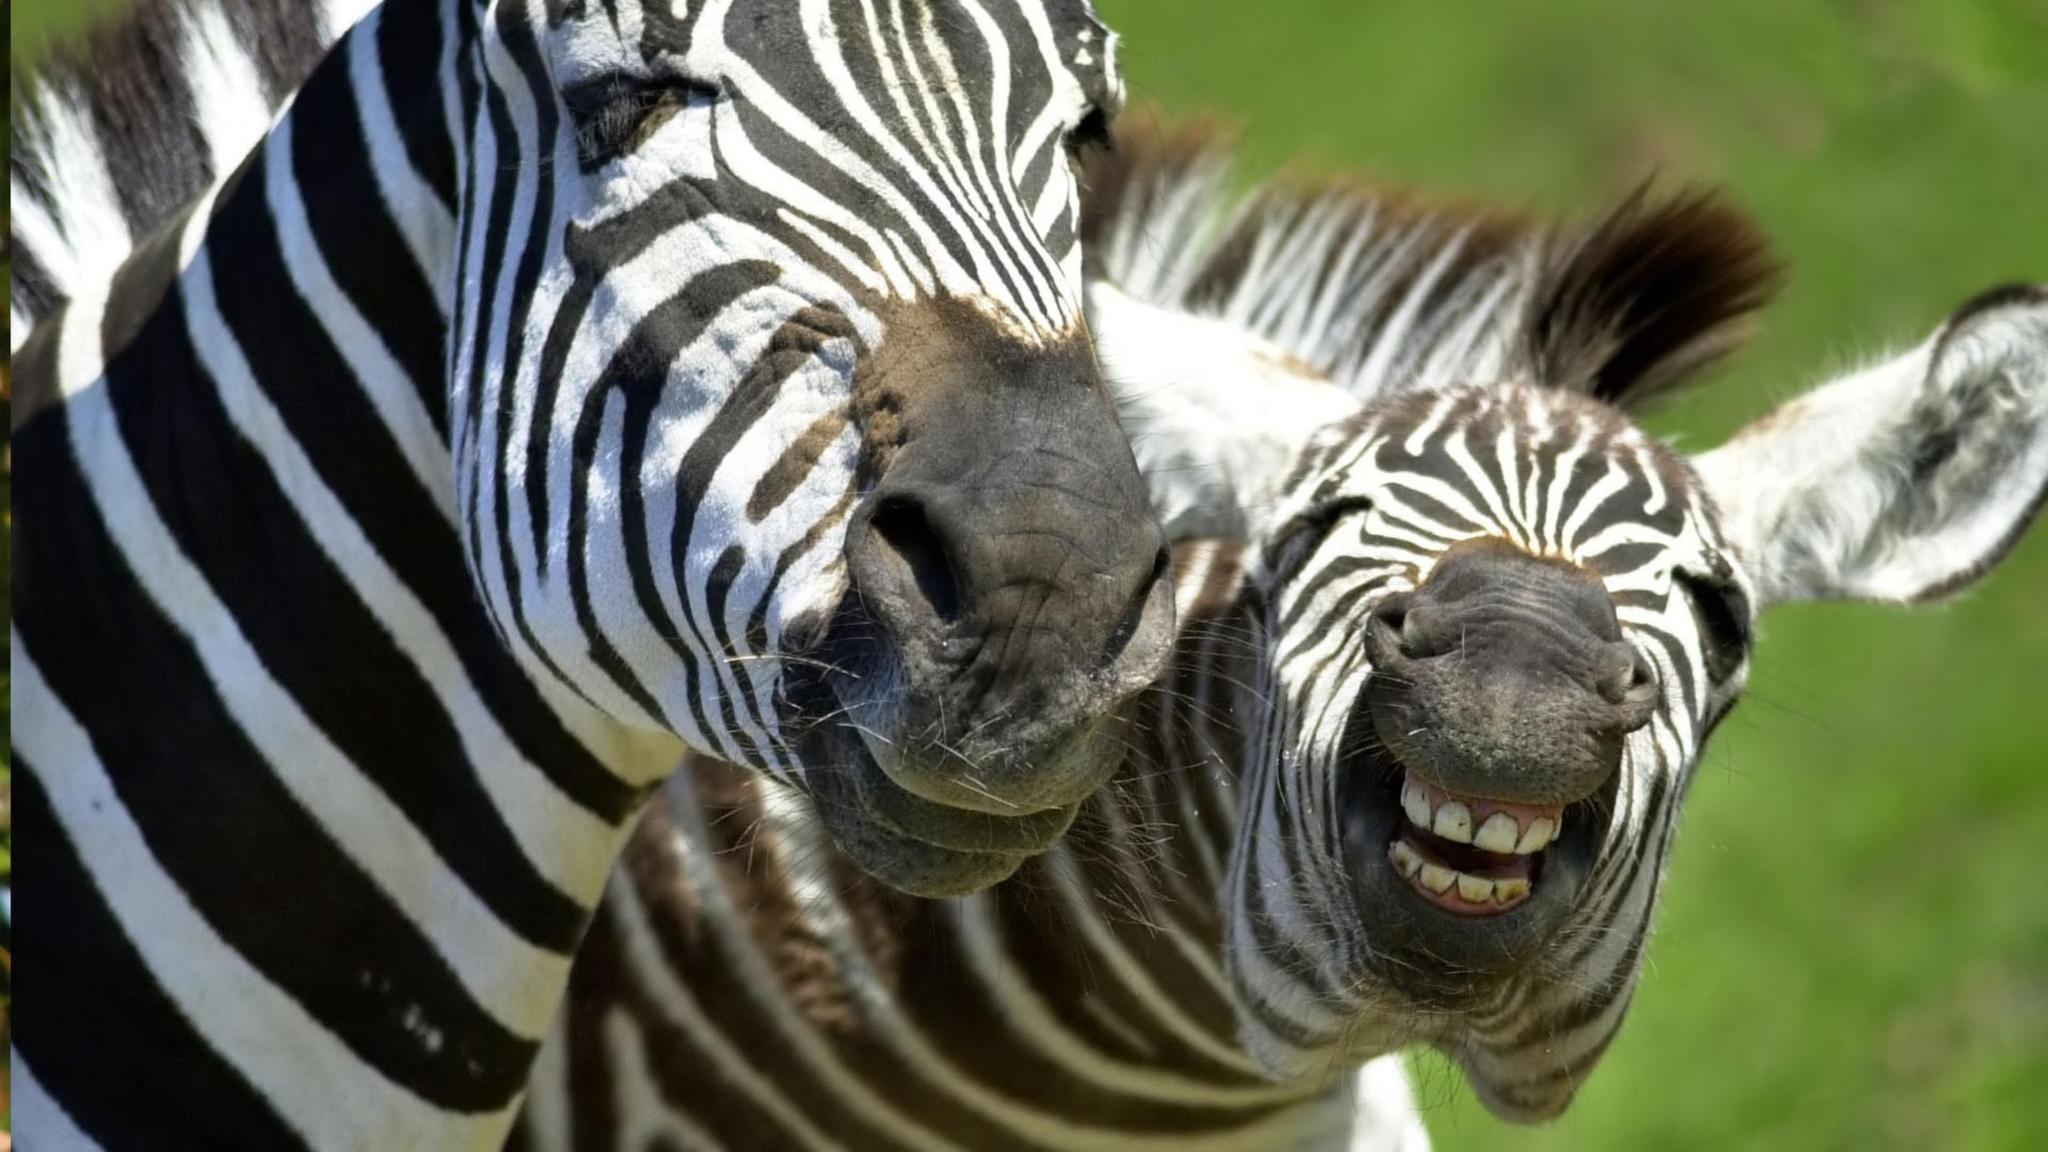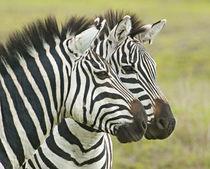The first image is the image on the left, the second image is the image on the right. For the images displayed, is the sentence "In one image, one zebra has its head over the back of a zebra with its rear facing the camera and its neck turned so it can look forward." factually correct? Answer yes or no. No. The first image is the image on the left, the second image is the image on the right. Given the left and right images, does the statement "in at least one image, there are two black and white striped zebra heads facing left." hold true? Answer yes or no. No. 